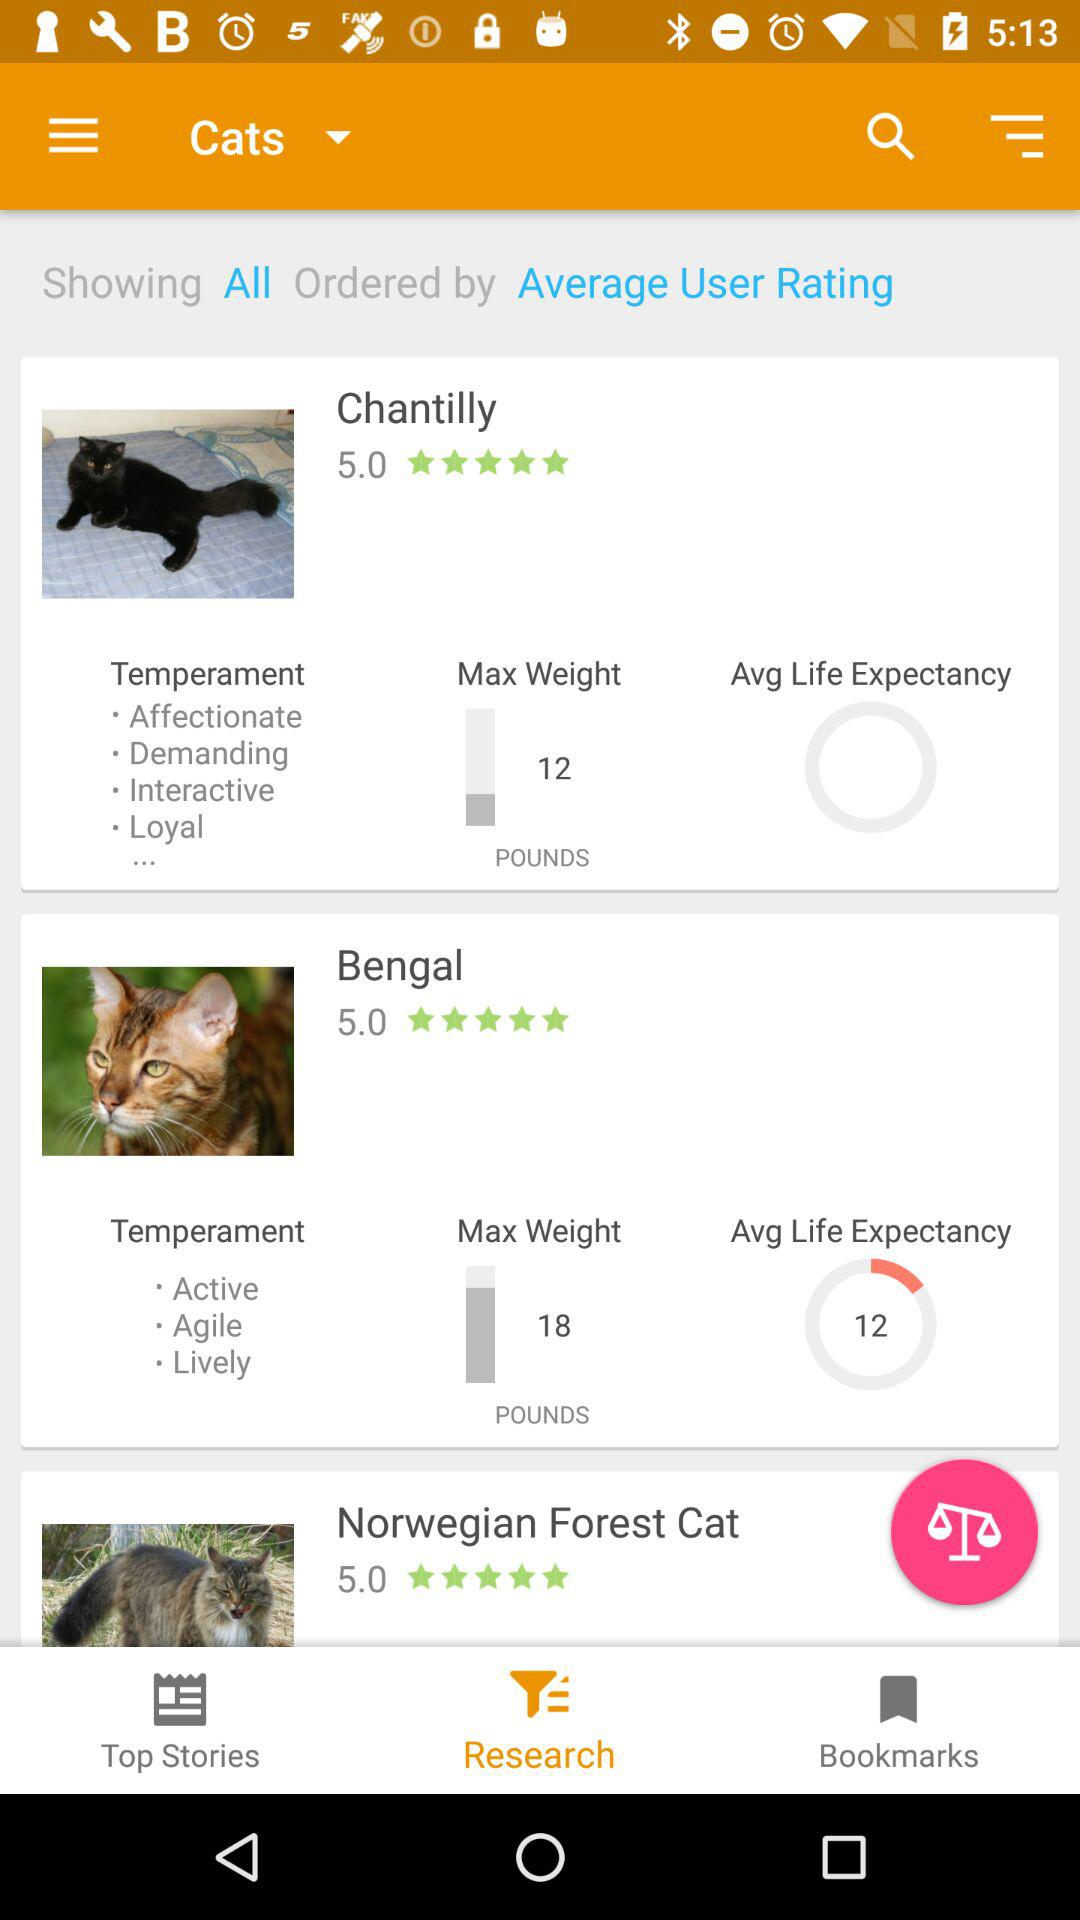What is the maximum weight of Chantilly? The maximum weight is 12 pounds. 